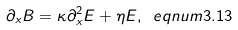Convert formula to latex. <formula><loc_0><loc_0><loc_500><loc_500>\partial _ { x } B = \kappa \partial _ { x } ^ { 2 } E + \eta E , \ e q n u m { 3 . 1 3 }</formula> 